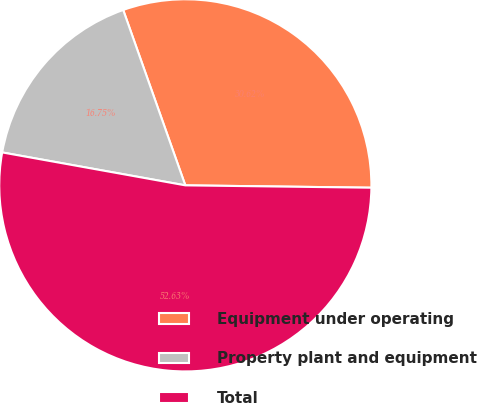Convert chart. <chart><loc_0><loc_0><loc_500><loc_500><pie_chart><fcel>Equipment under operating<fcel>Property plant and equipment<fcel>Total<nl><fcel>30.62%<fcel>16.75%<fcel>52.63%<nl></chart> 